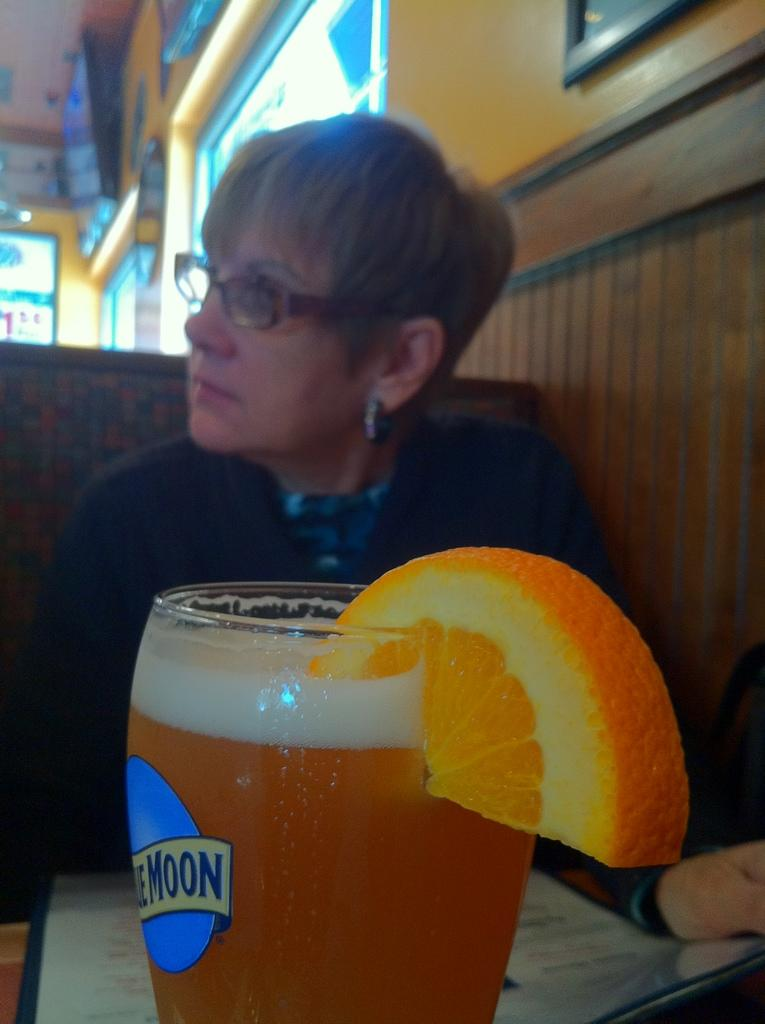Who is present in the image? There is a woman in the image. What is the woman wearing that helps her see better? The woman is wearing spectacles. What can be seen in the glass in the image? There is a drink in the glass. What type of fruit is present in the image? There is an orange slice in the image. What can be seen in the background of the image? There is a wall in the background of the image. What is hanging on the wall in the background? There are frames on the wall in the background. What type of science experiment is being conducted with the geese in the image? There are no geese present in the image, so no such experiment can be observed. Is the woman in the image smoking a pipe? There is no pipe visible in the image, and the woman is not smoking. 